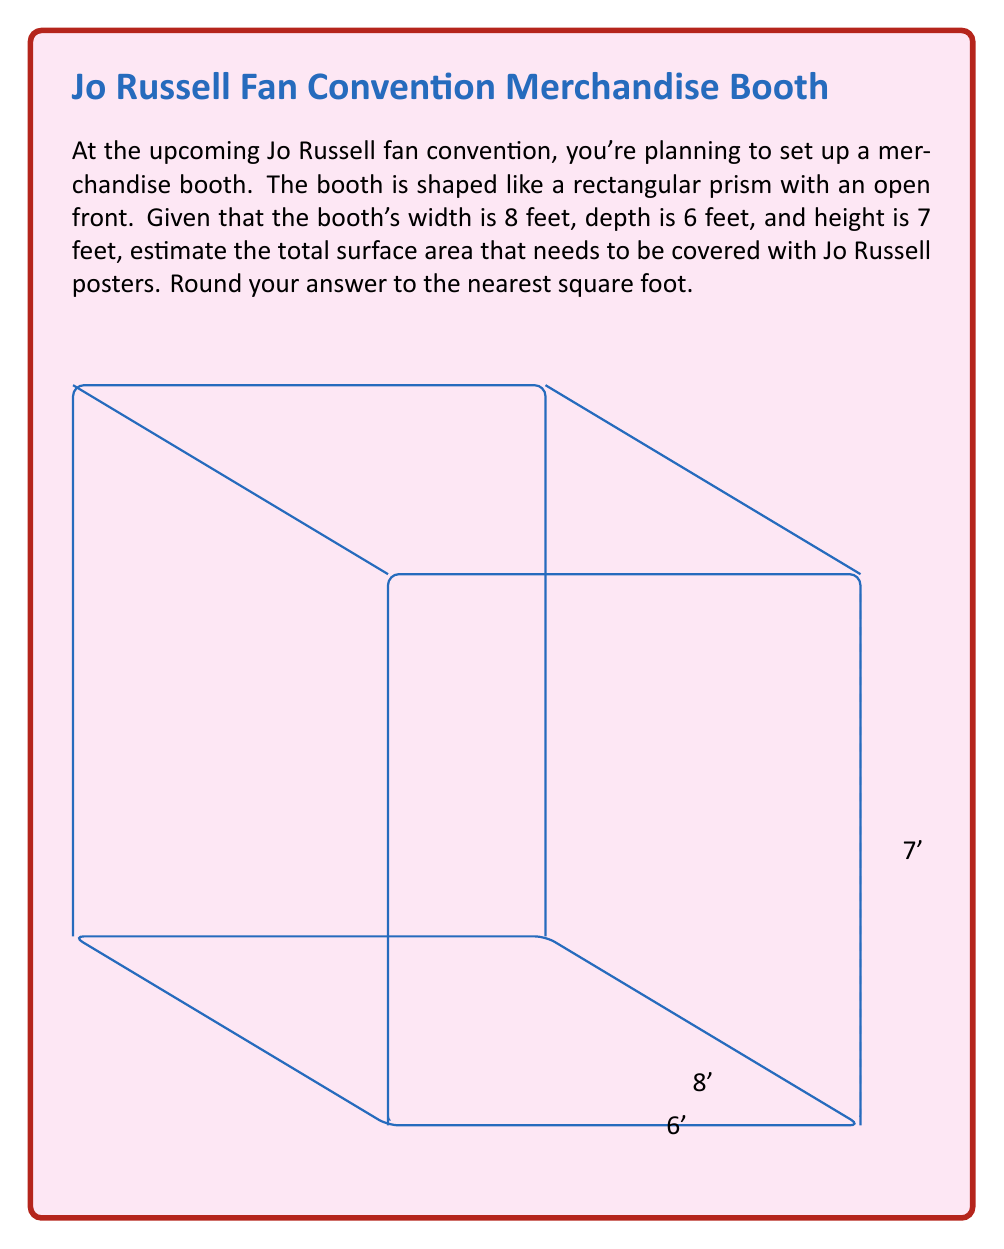Solve this math problem. Let's break this down step-by-step:

1) The booth is a rectangular prism with an open front. We need to calculate the surface area of 5 sides (top, bottom, back, and two sides).

2) Area of the top and bottom (each):
   $A_{top/bottom} = \text{width} \times \text{depth} = 8 \text{ ft} \times 6 \text{ ft} = 48 \text{ sq ft}$

3) Area of the back:
   $A_{back} = \text{width} \times \text{height} = 8 \text{ ft} \times 7 \text{ ft} = 56 \text{ sq ft}$

4) Area of each side:
   $A_{side} = \text{depth} \times \text{height} = 6 \text{ ft} \times 7 \text{ ft} = 42 \text{ sq ft}$

5) Total surface area:
   $$\begin{align}
   A_{total} &= A_{top} + A_{bottom} + A_{back} + 2 \times A_{side} \\
   &= 48 + 48 + 56 + 2(42) \\
   &= 152 + 84 \\
   &= 236 \text{ sq ft}
   \end{align}$$

6) Rounding to the nearest square foot:
   The result is already a whole number, so no rounding is necessary.

Therefore, you'll need approximately 236 square feet of surface area to cover with Jo Russell posters.
Answer: 236 sq ft 